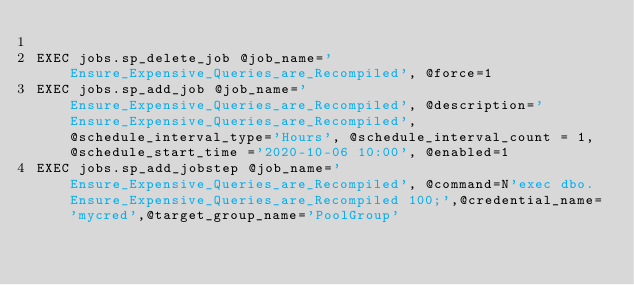<code> <loc_0><loc_0><loc_500><loc_500><_SQL_>
EXEC jobs.sp_delete_job @job_name='Ensure_Expensive_Queries_are_Recompiled', @force=1
EXEC jobs.sp_add_job @job_name='Ensure_Expensive_Queries_are_Recompiled', @description='Ensure_Expensive_Queries_are_Recompiled',  @schedule_interval_type='Hours', @schedule_interval_count = 1, @schedule_start_time ='2020-10-06 10:00', @enabled=1
EXEC jobs.sp_add_jobstep @job_name='Ensure_Expensive_Queries_are_Recompiled', @command=N'exec dbo.Ensure_Expensive_Queries_are_Recompiled 100;',@credential_name='mycred',@target_group_name='PoolGroup'

</code> 